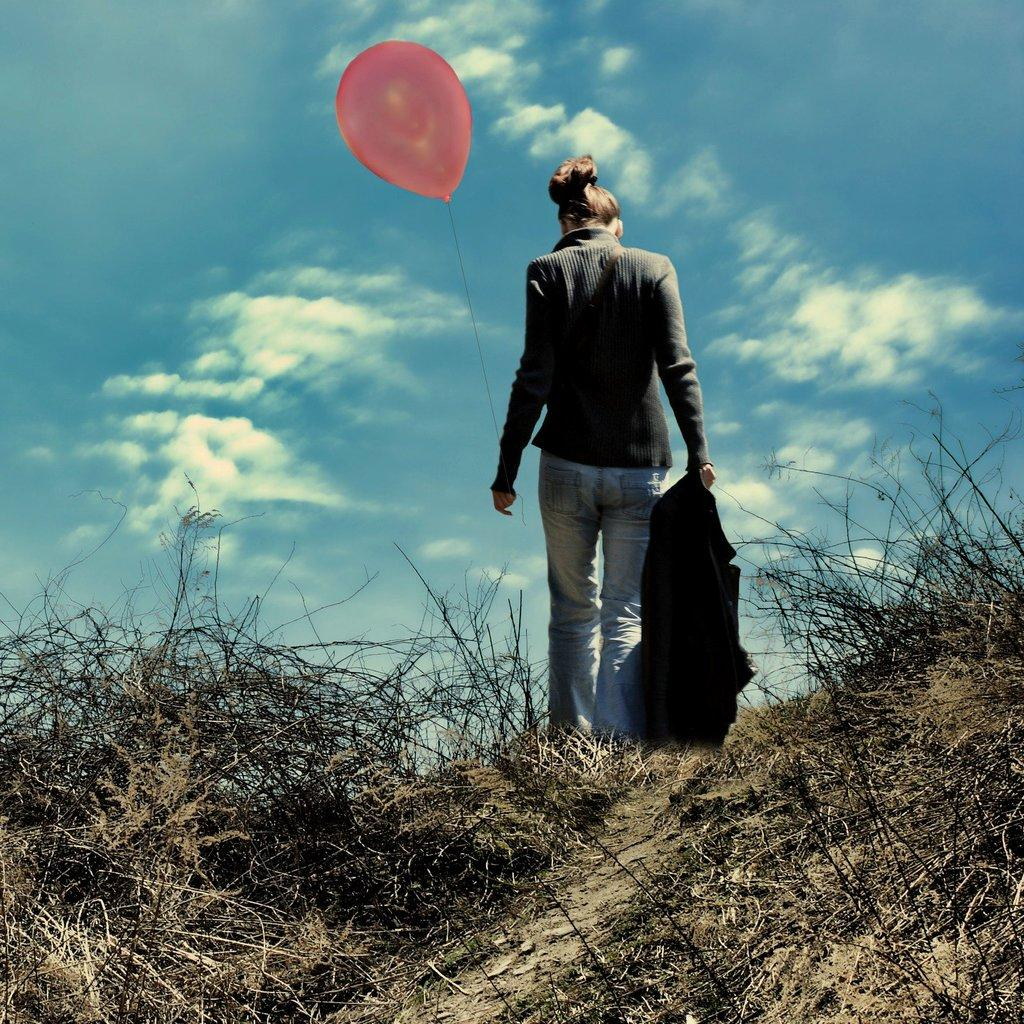Who is present in the image? There is a woman in the image. What is the woman holding in her left hand? The woman is holding a red balloon in her left hand. What is the woman holding in her right hand? The woman is holding a black jacket in her right hand. What can be seen in the background of the image? The sky is clear and blue in the background of the image. What type of desk is visible in the image? There is no desk present in the image. What trade is the woman involved in, as depicted in the image? The image does not provide any information about the woman's trade or occupation. 